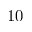Convert formula to latex. <formula><loc_0><loc_0><loc_500><loc_500>1 0</formula> 